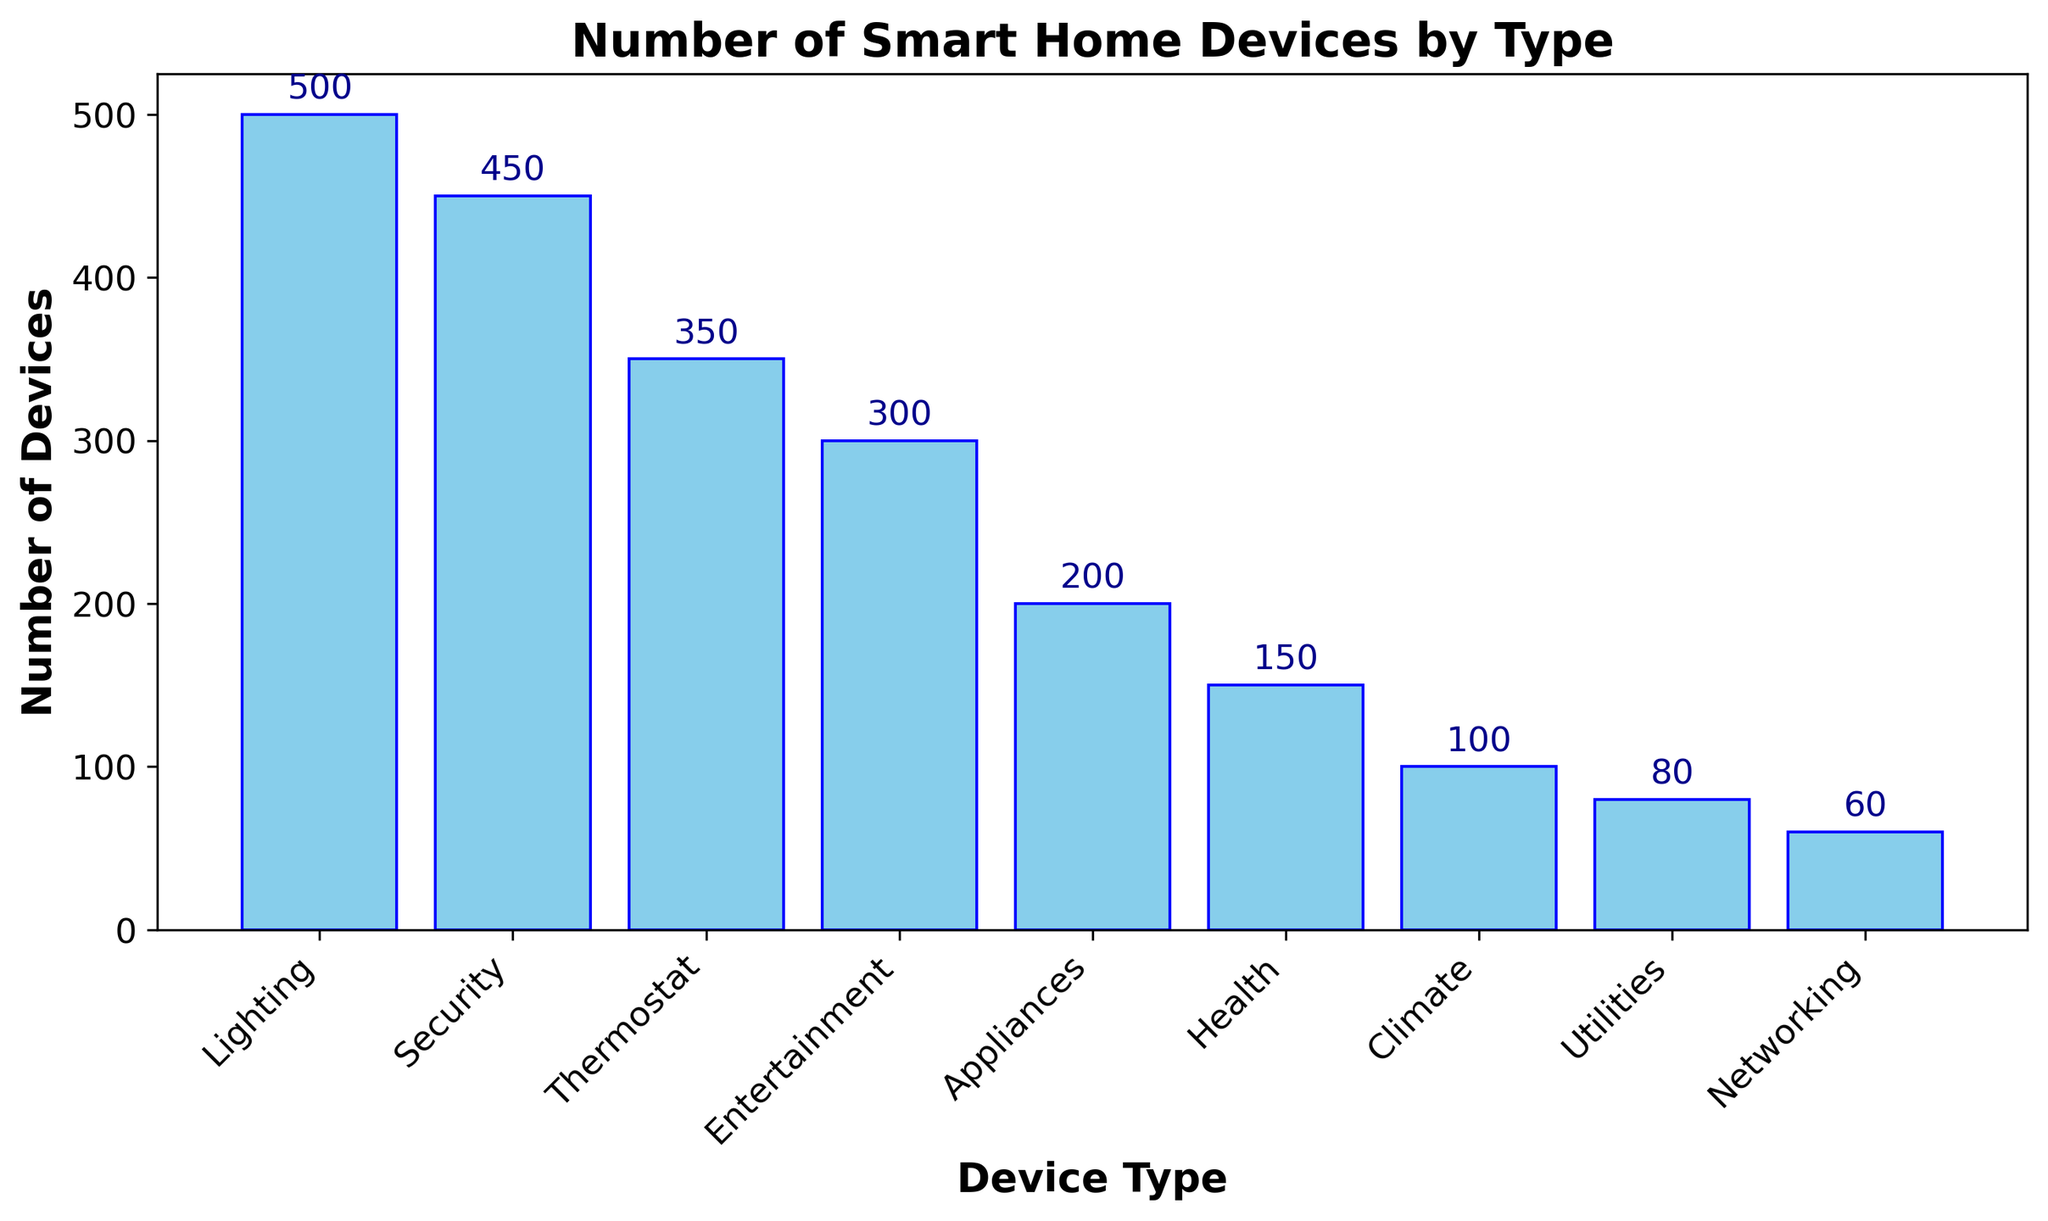How many more lighting devices are there compared to networking devices? To find this, subtract the number of networking devices from the number of lighting devices (500 - 60).
Answer: 440 What is the total number of devices for security, thermostat, and entertainment combined? Sum the number of devices for these three categories (450 + 350 + 300).
Answer: 1100 Which two device types have the smallest difference in their number of devices, and what is that difference? Compare the differences between the number of devices for each pair. The smallest difference is between climate (100) and health (150), which is 150 - 100.
Answer: Climate and Health, 50 Which device type is the most popular, and how many devices are there for this type? The tallest bar in the chart represents the most popular device type, which is lighting, with 500 devices.
Answer: Lighting, 500 What is the average number of devices for appliances, health, and utilities? Sum the number of devices for these three types and then divide by 3 ((200 + 150 + 80) / 3).
Answer: 143.3 How many device types have more than 300 devices? Count the number of bars taller than 300. These are lighting, security, and thermostat.
Answer: 3 What is the difference between the number of thermostat and entertainment devices? To find this, subtract the number of entertainment devices from the number of thermostat devices (350 - 300).
Answer: 50 Which device type has the fewest number of devices? The shortest bar represents the device type with the fewest devices, which is networking with 60 devices.
Answer: Networking, 60 Rank the device types from most to least number of devices. Order the device types by the height of their corresponding bars from tallest to shortest.
Answer: Lighting, Security, Thermostat, Entertainment, Appliances, Health, Climate, Utilities, Networking 